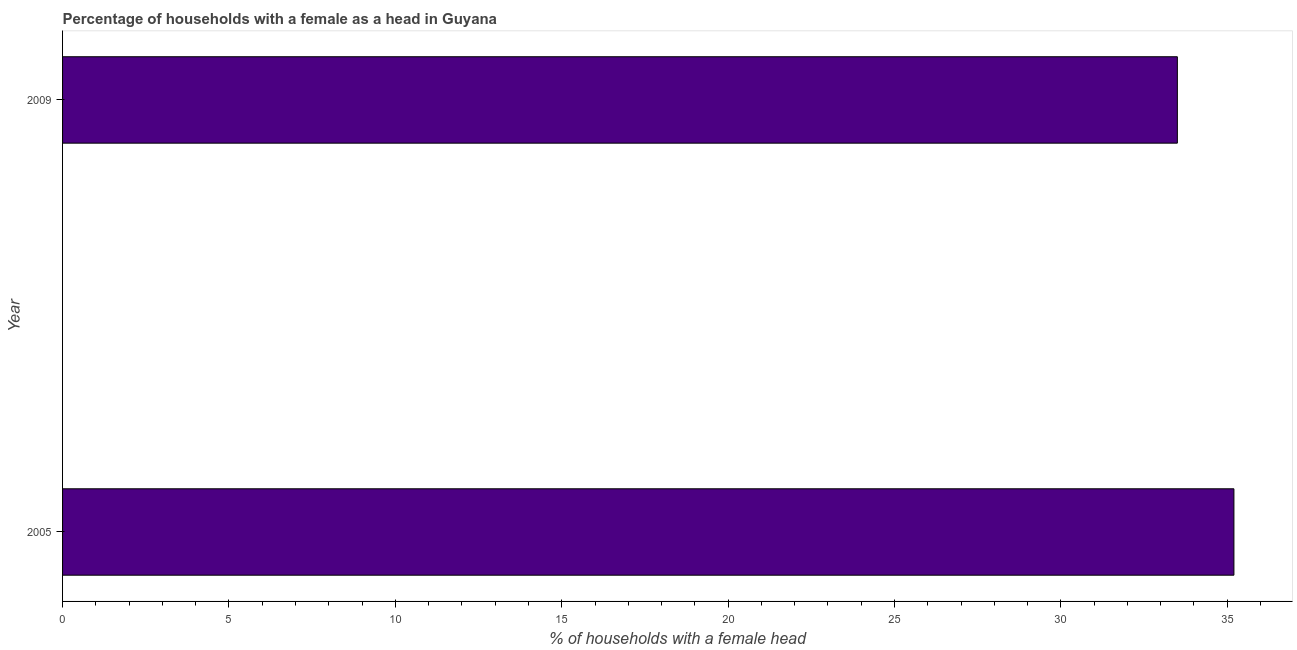Does the graph contain any zero values?
Give a very brief answer. No. What is the title of the graph?
Give a very brief answer. Percentage of households with a female as a head in Guyana. What is the label or title of the X-axis?
Offer a very short reply. % of households with a female head. What is the label or title of the Y-axis?
Offer a very short reply. Year. What is the number of female supervised households in 2005?
Your answer should be very brief. 35.2. Across all years, what is the maximum number of female supervised households?
Provide a succinct answer. 35.2. Across all years, what is the minimum number of female supervised households?
Give a very brief answer. 33.5. In which year was the number of female supervised households minimum?
Offer a very short reply. 2009. What is the sum of the number of female supervised households?
Offer a terse response. 68.7. What is the average number of female supervised households per year?
Your answer should be compact. 34.35. What is the median number of female supervised households?
Provide a succinct answer. 34.35. What is the ratio of the number of female supervised households in 2005 to that in 2009?
Your response must be concise. 1.05. How many bars are there?
Offer a very short reply. 2. How many years are there in the graph?
Ensure brevity in your answer.  2. What is the difference between two consecutive major ticks on the X-axis?
Offer a very short reply. 5. What is the % of households with a female head of 2005?
Make the answer very short. 35.2. What is the % of households with a female head in 2009?
Give a very brief answer. 33.5. What is the ratio of the % of households with a female head in 2005 to that in 2009?
Provide a succinct answer. 1.05. 